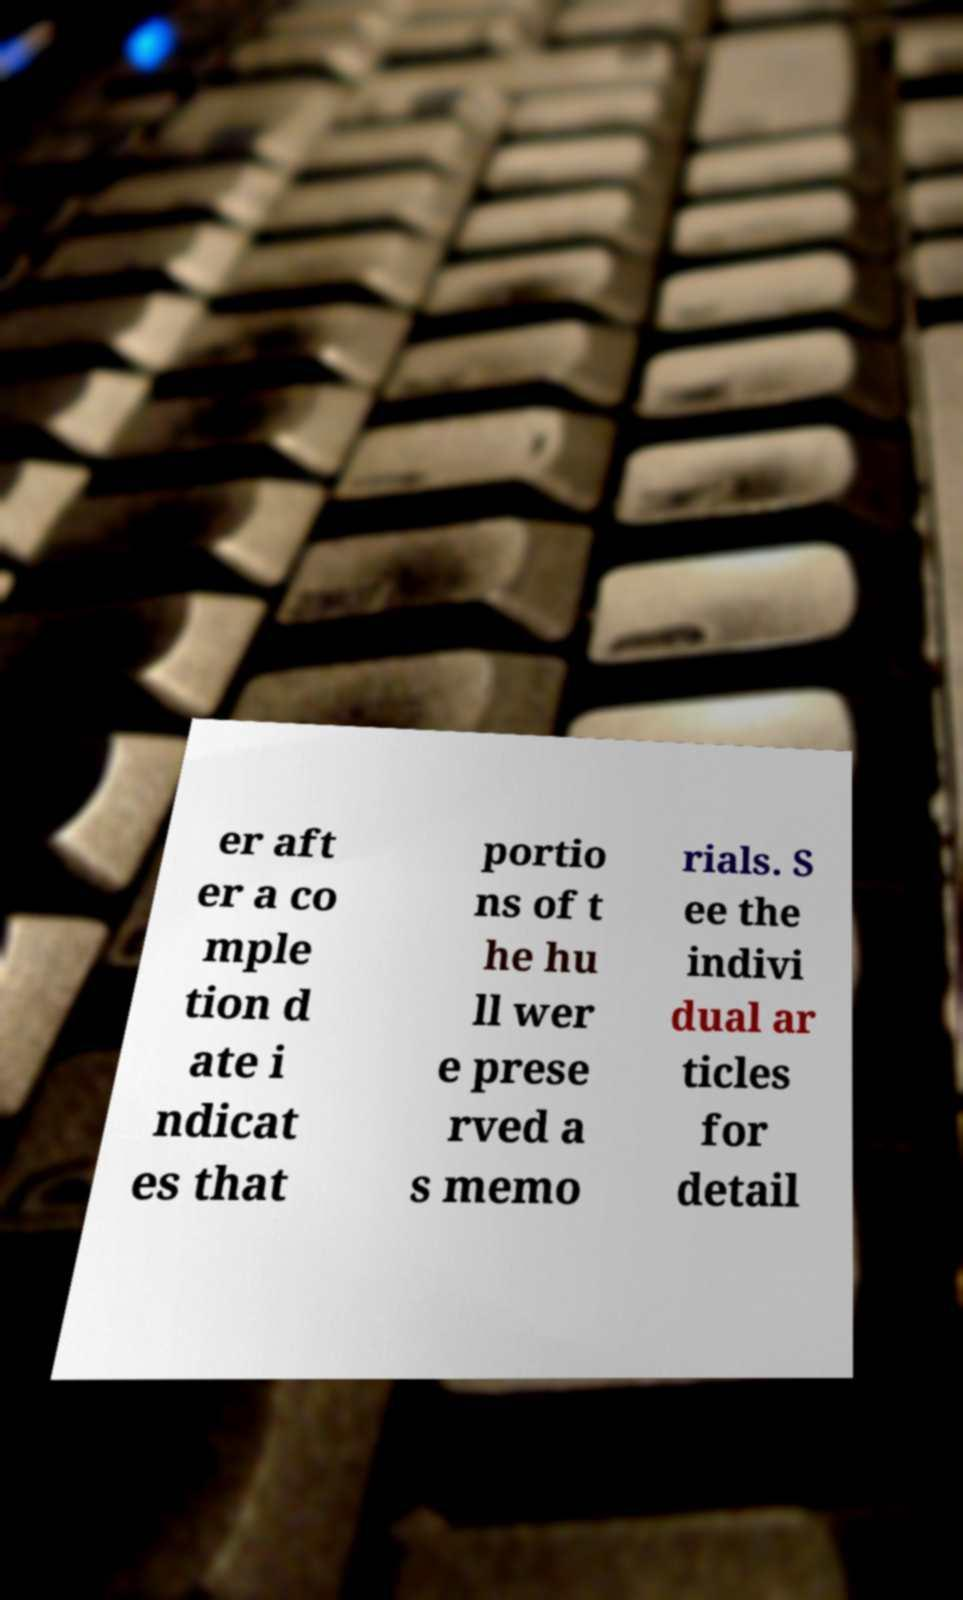Please identify and transcribe the text found in this image. er aft er a co mple tion d ate i ndicat es that portio ns of t he hu ll wer e prese rved a s memo rials. S ee the indivi dual ar ticles for detail 